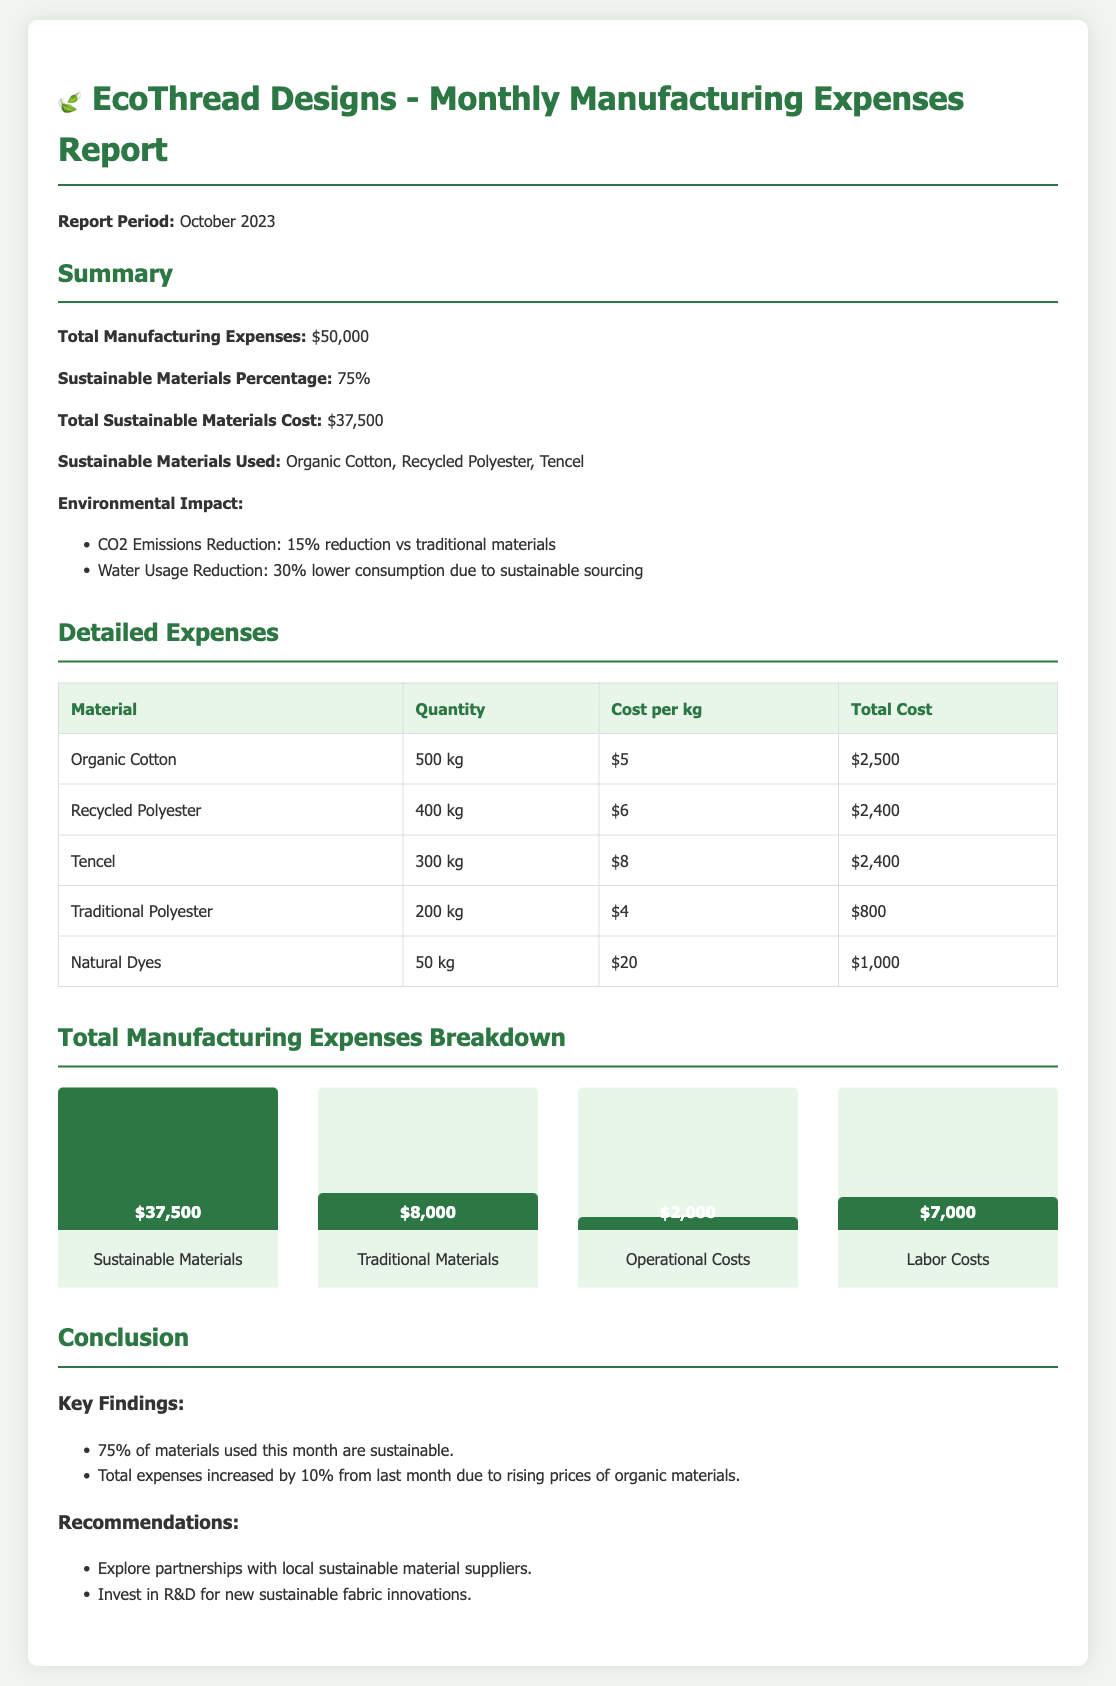what is the total manufacturing expenses? The total manufacturing expenses are stated as $50,000 in the summary section of the report.
Answer: $50,000 what is the sustainable materials percentage? The sustainable materials percentage, as mentioned in the summary, is 75%.
Answer: 75% what is the total cost of sustainable materials? The total cost of sustainable materials is listed as $37,500 in the report.
Answer: $37,500 which sustainable materials were used? The report specifies the sustainable materials used as Organic Cotton, Recycled Polyester, and Tencel.
Answer: Organic Cotton, Recycled Polyester, Tencel what percentage reduction in CO2 emissions is reported? The document mentions a 15% reduction in CO2 emissions compared to traditional materials.
Answer: 15% how much did the total expenses increase compared to last month? The total expenses increased by 10% from last month due to rising prices of organic materials, as stated in the conclusion.
Answer: 10% what is the total cost for traditional polyester? The document shows that the total cost for traditional polyester is $800.
Answer: $800 what is the breakdown amount for labor costs? The breakdown amount for labor costs is indicated as $7,000 in the chart section of the report.
Answer: $7,000 what recommendation is made regarding material suppliers? One recommendation in the report suggests exploring partnerships with local sustainable material suppliers.
Answer: partnerships with local sustainable material suppliers 